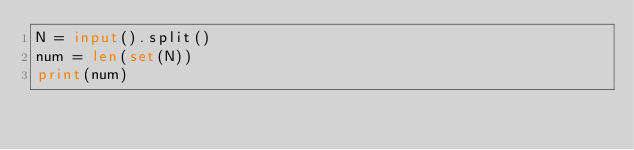<code> <loc_0><loc_0><loc_500><loc_500><_Python_>N = input().split()
num = len(set(N))
print(num)
</code> 